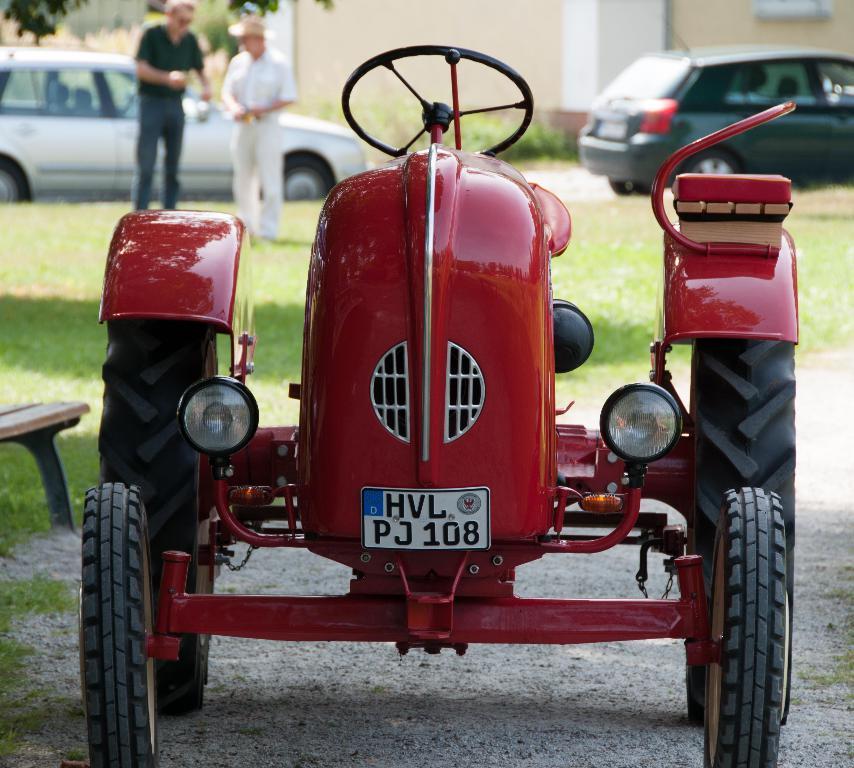How would you summarize this image in a sentence or two? It is a tractor which is in red color. On the left side 2 men are standing on the grass, few cars are parked on the road. 